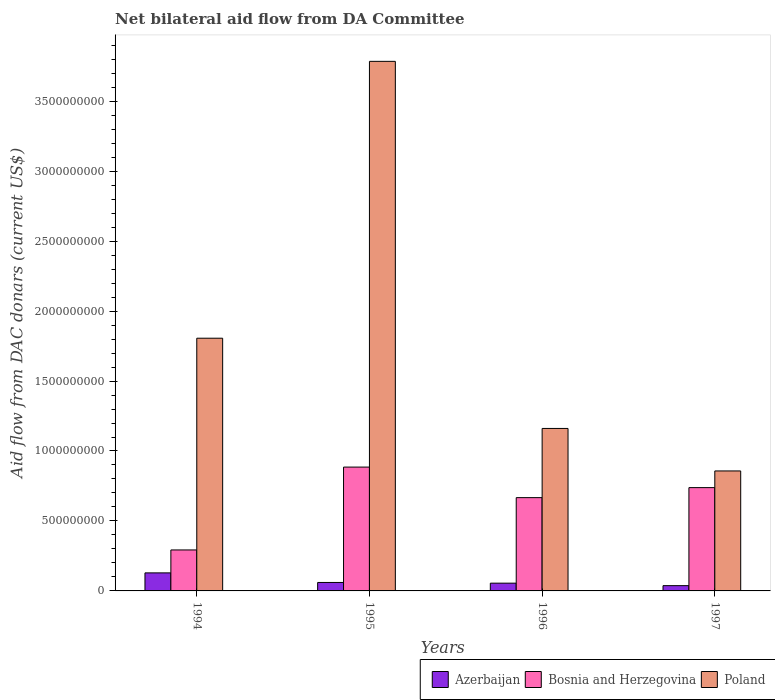How many bars are there on the 2nd tick from the left?
Your response must be concise. 3. What is the label of the 2nd group of bars from the left?
Make the answer very short. 1995. In how many cases, is the number of bars for a given year not equal to the number of legend labels?
Offer a terse response. 0. What is the aid flow in in Azerbaijan in 1995?
Your answer should be very brief. 6.05e+07. Across all years, what is the maximum aid flow in in Poland?
Provide a short and direct response. 3.78e+09. Across all years, what is the minimum aid flow in in Bosnia and Herzegovina?
Offer a terse response. 2.93e+08. In which year was the aid flow in in Azerbaijan maximum?
Offer a terse response. 1994. In which year was the aid flow in in Bosnia and Herzegovina minimum?
Ensure brevity in your answer.  1994. What is the total aid flow in in Azerbaijan in the graph?
Keep it short and to the point. 2.82e+08. What is the difference between the aid flow in in Bosnia and Herzegovina in 1995 and that in 1997?
Provide a short and direct response. 1.47e+08. What is the difference between the aid flow in in Azerbaijan in 1996 and the aid flow in in Bosnia and Herzegovina in 1995?
Your answer should be very brief. -8.30e+08. What is the average aid flow in in Poland per year?
Give a very brief answer. 1.90e+09. In the year 1996, what is the difference between the aid flow in in Azerbaijan and aid flow in in Poland?
Make the answer very short. -1.11e+09. What is the ratio of the aid flow in in Azerbaijan in 1994 to that in 1997?
Your response must be concise. 3.42. Is the difference between the aid flow in in Azerbaijan in 1995 and 1996 greater than the difference between the aid flow in in Poland in 1995 and 1996?
Keep it short and to the point. No. What is the difference between the highest and the second highest aid flow in in Bosnia and Herzegovina?
Your answer should be compact. 1.47e+08. What is the difference between the highest and the lowest aid flow in in Poland?
Provide a succinct answer. 2.93e+09. In how many years, is the aid flow in in Azerbaijan greater than the average aid flow in in Azerbaijan taken over all years?
Keep it short and to the point. 1. What does the 2nd bar from the left in 1996 represents?
Provide a succinct answer. Bosnia and Herzegovina. What does the 1st bar from the right in 1996 represents?
Your answer should be very brief. Poland. How many bars are there?
Offer a terse response. 12. Where does the legend appear in the graph?
Your answer should be very brief. Bottom right. How many legend labels are there?
Make the answer very short. 3. What is the title of the graph?
Provide a short and direct response. Net bilateral aid flow from DA Committee. Does "Bulgaria" appear as one of the legend labels in the graph?
Give a very brief answer. No. What is the label or title of the Y-axis?
Your answer should be compact. Aid flow from DAC donars (current US$). What is the Aid flow from DAC donars (current US$) in Azerbaijan in 1994?
Provide a short and direct response. 1.29e+08. What is the Aid flow from DAC donars (current US$) of Bosnia and Herzegovina in 1994?
Provide a short and direct response. 2.93e+08. What is the Aid flow from DAC donars (current US$) of Poland in 1994?
Your response must be concise. 1.81e+09. What is the Aid flow from DAC donars (current US$) of Azerbaijan in 1995?
Keep it short and to the point. 6.05e+07. What is the Aid flow from DAC donars (current US$) of Bosnia and Herzegovina in 1995?
Keep it short and to the point. 8.85e+08. What is the Aid flow from DAC donars (current US$) in Poland in 1995?
Your answer should be compact. 3.78e+09. What is the Aid flow from DAC donars (current US$) in Azerbaijan in 1996?
Provide a succinct answer. 5.54e+07. What is the Aid flow from DAC donars (current US$) in Bosnia and Herzegovina in 1996?
Offer a very short reply. 6.67e+08. What is the Aid flow from DAC donars (current US$) of Poland in 1996?
Ensure brevity in your answer.  1.16e+09. What is the Aid flow from DAC donars (current US$) of Azerbaijan in 1997?
Your answer should be compact. 3.76e+07. What is the Aid flow from DAC donars (current US$) in Bosnia and Herzegovina in 1997?
Make the answer very short. 7.38e+08. What is the Aid flow from DAC donars (current US$) in Poland in 1997?
Make the answer very short. 8.57e+08. Across all years, what is the maximum Aid flow from DAC donars (current US$) of Azerbaijan?
Your answer should be compact. 1.29e+08. Across all years, what is the maximum Aid flow from DAC donars (current US$) of Bosnia and Herzegovina?
Keep it short and to the point. 8.85e+08. Across all years, what is the maximum Aid flow from DAC donars (current US$) of Poland?
Provide a succinct answer. 3.78e+09. Across all years, what is the minimum Aid flow from DAC donars (current US$) in Azerbaijan?
Ensure brevity in your answer.  3.76e+07. Across all years, what is the minimum Aid flow from DAC donars (current US$) in Bosnia and Herzegovina?
Keep it short and to the point. 2.93e+08. Across all years, what is the minimum Aid flow from DAC donars (current US$) of Poland?
Make the answer very short. 8.57e+08. What is the total Aid flow from DAC donars (current US$) of Azerbaijan in the graph?
Give a very brief answer. 2.82e+08. What is the total Aid flow from DAC donars (current US$) of Bosnia and Herzegovina in the graph?
Give a very brief answer. 2.58e+09. What is the total Aid flow from DAC donars (current US$) in Poland in the graph?
Provide a short and direct response. 7.61e+09. What is the difference between the Aid flow from DAC donars (current US$) of Azerbaijan in 1994 and that in 1995?
Offer a terse response. 6.84e+07. What is the difference between the Aid flow from DAC donars (current US$) of Bosnia and Herzegovina in 1994 and that in 1995?
Give a very brief answer. -5.92e+08. What is the difference between the Aid flow from DAC donars (current US$) in Poland in 1994 and that in 1995?
Make the answer very short. -1.98e+09. What is the difference between the Aid flow from DAC donars (current US$) in Azerbaijan in 1994 and that in 1996?
Your answer should be compact. 7.34e+07. What is the difference between the Aid flow from DAC donars (current US$) of Bosnia and Herzegovina in 1994 and that in 1996?
Offer a terse response. -3.74e+08. What is the difference between the Aid flow from DAC donars (current US$) in Poland in 1994 and that in 1996?
Make the answer very short. 6.45e+08. What is the difference between the Aid flow from DAC donars (current US$) of Azerbaijan in 1994 and that in 1997?
Your answer should be compact. 9.12e+07. What is the difference between the Aid flow from DAC donars (current US$) of Bosnia and Herzegovina in 1994 and that in 1997?
Provide a short and direct response. -4.45e+08. What is the difference between the Aid flow from DAC donars (current US$) in Poland in 1994 and that in 1997?
Your answer should be compact. 9.49e+08. What is the difference between the Aid flow from DAC donars (current US$) of Azerbaijan in 1995 and that in 1996?
Offer a terse response. 5.03e+06. What is the difference between the Aid flow from DAC donars (current US$) of Bosnia and Herzegovina in 1995 and that in 1996?
Ensure brevity in your answer.  2.18e+08. What is the difference between the Aid flow from DAC donars (current US$) in Poland in 1995 and that in 1996?
Provide a short and direct response. 2.62e+09. What is the difference between the Aid flow from DAC donars (current US$) of Azerbaijan in 1995 and that in 1997?
Keep it short and to the point. 2.28e+07. What is the difference between the Aid flow from DAC donars (current US$) in Bosnia and Herzegovina in 1995 and that in 1997?
Your response must be concise. 1.47e+08. What is the difference between the Aid flow from DAC donars (current US$) in Poland in 1995 and that in 1997?
Ensure brevity in your answer.  2.93e+09. What is the difference between the Aid flow from DAC donars (current US$) in Azerbaijan in 1996 and that in 1997?
Provide a short and direct response. 1.78e+07. What is the difference between the Aid flow from DAC donars (current US$) in Bosnia and Herzegovina in 1996 and that in 1997?
Your response must be concise. -7.16e+07. What is the difference between the Aid flow from DAC donars (current US$) in Poland in 1996 and that in 1997?
Your response must be concise. 3.04e+08. What is the difference between the Aid flow from DAC donars (current US$) in Azerbaijan in 1994 and the Aid flow from DAC donars (current US$) in Bosnia and Herzegovina in 1995?
Your answer should be compact. -7.56e+08. What is the difference between the Aid flow from DAC donars (current US$) in Azerbaijan in 1994 and the Aid flow from DAC donars (current US$) in Poland in 1995?
Offer a very short reply. -3.66e+09. What is the difference between the Aid flow from DAC donars (current US$) in Bosnia and Herzegovina in 1994 and the Aid flow from DAC donars (current US$) in Poland in 1995?
Ensure brevity in your answer.  -3.49e+09. What is the difference between the Aid flow from DAC donars (current US$) in Azerbaijan in 1994 and the Aid flow from DAC donars (current US$) in Bosnia and Herzegovina in 1996?
Provide a succinct answer. -5.38e+08. What is the difference between the Aid flow from DAC donars (current US$) in Azerbaijan in 1994 and the Aid flow from DAC donars (current US$) in Poland in 1996?
Your answer should be very brief. -1.03e+09. What is the difference between the Aid flow from DAC donars (current US$) in Bosnia and Herzegovina in 1994 and the Aid flow from DAC donars (current US$) in Poland in 1996?
Your answer should be very brief. -8.68e+08. What is the difference between the Aid flow from DAC donars (current US$) of Azerbaijan in 1994 and the Aid flow from DAC donars (current US$) of Bosnia and Herzegovina in 1997?
Keep it short and to the point. -6.09e+08. What is the difference between the Aid flow from DAC donars (current US$) of Azerbaijan in 1994 and the Aid flow from DAC donars (current US$) of Poland in 1997?
Your response must be concise. -7.29e+08. What is the difference between the Aid flow from DAC donars (current US$) of Bosnia and Herzegovina in 1994 and the Aid flow from DAC donars (current US$) of Poland in 1997?
Offer a very short reply. -5.65e+08. What is the difference between the Aid flow from DAC donars (current US$) of Azerbaijan in 1995 and the Aid flow from DAC donars (current US$) of Bosnia and Herzegovina in 1996?
Give a very brief answer. -6.06e+08. What is the difference between the Aid flow from DAC donars (current US$) in Azerbaijan in 1995 and the Aid flow from DAC donars (current US$) in Poland in 1996?
Make the answer very short. -1.10e+09. What is the difference between the Aid flow from DAC donars (current US$) in Bosnia and Herzegovina in 1995 and the Aid flow from DAC donars (current US$) in Poland in 1996?
Provide a succinct answer. -2.76e+08. What is the difference between the Aid flow from DAC donars (current US$) in Azerbaijan in 1995 and the Aid flow from DAC donars (current US$) in Bosnia and Herzegovina in 1997?
Offer a terse response. -6.78e+08. What is the difference between the Aid flow from DAC donars (current US$) in Azerbaijan in 1995 and the Aid flow from DAC donars (current US$) in Poland in 1997?
Your response must be concise. -7.97e+08. What is the difference between the Aid flow from DAC donars (current US$) in Bosnia and Herzegovina in 1995 and the Aid flow from DAC donars (current US$) in Poland in 1997?
Offer a very short reply. 2.76e+07. What is the difference between the Aid flow from DAC donars (current US$) in Azerbaijan in 1996 and the Aid flow from DAC donars (current US$) in Bosnia and Herzegovina in 1997?
Provide a short and direct response. -6.83e+08. What is the difference between the Aid flow from DAC donars (current US$) in Azerbaijan in 1996 and the Aid flow from DAC donars (current US$) in Poland in 1997?
Offer a terse response. -8.02e+08. What is the difference between the Aid flow from DAC donars (current US$) of Bosnia and Herzegovina in 1996 and the Aid flow from DAC donars (current US$) of Poland in 1997?
Provide a succinct answer. -1.91e+08. What is the average Aid flow from DAC donars (current US$) of Azerbaijan per year?
Your answer should be very brief. 7.06e+07. What is the average Aid flow from DAC donars (current US$) in Bosnia and Herzegovina per year?
Provide a succinct answer. 6.46e+08. What is the average Aid flow from DAC donars (current US$) of Poland per year?
Make the answer very short. 1.90e+09. In the year 1994, what is the difference between the Aid flow from DAC donars (current US$) in Azerbaijan and Aid flow from DAC donars (current US$) in Bosnia and Herzegovina?
Make the answer very short. -1.64e+08. In the year 1994, what is the difference between the Aid flow from DAC donars (current US$) in Azerbaijan and Aid flow from DAC donars (current US$) in Poland?
Your answer should be very brief. -1.68e+09. In the year 1994, what is the difference between the Aid flow from DAC donars (current US$) in Bosnia and Herzegovina and Aid flow from DAC donars (current US$) in Poland?
Give a very brief answer. -1.51e+09. In the year 1995, what is the difference between the Aid flow from DAC donars (current US$) in Azerbaijan and Aid flow from DAC donars (current US$) in Bosnia and Herzegovina?
Offer a terse response. -8.25e+08. In the year 1995, what is the difference between the Aid flow from DAC donars (current US$) in Azerbaijan and Aid flow from DAC donars (current US$) in Poland?
Your answer should be very brief. -3.72e+09. In the year 1995, what is the difference between the Aid flow from DAC donars (current US$) of Bosnia and Herzegovina and Aid flow from DAC donars (current US$) of Poland?
Give a very brief answer. -2.90e+09. In the year 1996, what is the difference between the Aid flow from DAC donars (current US$) of Azerbaijan and Aid flow from DAC donars (current US$) of Bosnia and Herzegovina?
Offer a very short reply. -6.11e+08. In the year 1996, what is the difference between the Aid flow from DAC donars (current US$) of Azerbaijan and Aid flow from DAC donars (current US$) of Poland?
Your answer should be compact. -1.11e+09. In the year 1996, what is the difference between the Aid flow from DAC donars (current US$) in Bosnia and Herzegovina and Aid flow from DAC donars (current US$) in Poland?
Your answer should be compact. -4.94e+08. In the year 1997, what is the difference between the Aid flow from DAC donars (current US$) of Azerbaijan and Aid flow from DAC donars (current US$) of Bosnia and Herzegovina?
Your answer should be very brief. -7.01e+08. In the year 1997, what is the difference between the Aid flow from DAC donars (current US$) of Azerbaijan and Aid flow from DAC donars (current US$) of Poland?
Offer a terse response. -8.20e+08. In the year 1997, what is the difference between the Aid flow from DAC donars (current US$) in Bosnia and Herzegovina and Aid flow from DAC donars (current US$) in Poland?
Your answer should be compact. -1.19e+08. What is the ratio of the Aid flow from DAC donars (current US$) in Azerbaijan in 1994 to that in 1995?
Provide a succinct answer. 2.13. What is the ratio of the Aid flow from DAC donars (current US$) in Bosnia and Herzegovina in 1994 to that in 1995?
Offer a terse response. 0.33. What is the ratio of the Aid flow from DAC donars (current US$) of Poland in 1994 to that in 1995?
Ensure brevity in your answer.  0.48. What is the ratio of the Aid flow from DAC donars (current US$) of Azerbaijan in 1994 to that in 1996?
Ensure brevity in your answer.  2.32. What is the ratio of the Aid flow from DAC donars (current US$) of Bosnia and Herzegovina in 1994 to that in 1996?
Your answer should be very brief. 0.44. What is the ratio of the Aid flow from DAC donars (current US$) of Poland in 1994 to that in 1996?
Make the answer very short. 1.56. What is the ratio of the Aid flow from DAC donars (current US$) of Azerbaijan in 1994 to that in 1997?
Ensure brevity in your answer.  3.42. What is the ratio of the Aid flow from DAC donars (current US$) in Bosnia and Herzegovina in 1994 to that in 1997?
Ensure brevity in your answer.  0.4. What is the ratio of the Aid flow from DAC donars (current US$) of Poland in 1994 to that in 1997?
Provide a short and direct response. 2.11. What is the ratio of the Aid flow from DAC donars (current US$) in Azerbaijan in 1995 to that in 1996?
Provide a succinct answer. 1.09. What is the ratio of the Aid flow from DAC donars (current US$) of Bosnia and Herzegovina in 1995 to that in 1996?
Keep it short and to the point. 1.33. What is the ratio of the Aid flow from DAC donars (current US$) of Poland in 1995 to that in 1996?
Provide a succinct answer. 3.26. What is the ratio of the Aid flow from DAC donars (current US$) in Azerbaijan in 1995 to that in 1997?
Your answer should be very brief. 1.61. What is the ratio of the Aid flow from DAC donars (current US$) in Bosnia and Herzegovina in 1995 to that in 1997?
Your answer should be compact. 1.2. What is the ratio of the Aid flow from DAC donars (current US$) in Poland in 1995 to that in 1997?
Your response must be concise. 4.41. What is the ratio of the Aid flow from DAC donars (current US$) in Azerbaijan in 1996 to that in 1997?
Ensure brevity in your answer.  1.47. What is the ratio of the Aid flow from DAC donars (current US$) in Bosnia and Herzegovina in 1996 to that in 1997?
Ensure brevity in your answer.  0.9. What is the ratio of the Aid flow from DAC donars (current US$) in Poland in 1996 to that in 1997?
Offer a very short reply. 1.35. What is the difference between the highest and the second highest Aid flow from DAC donars (current US$) of Azerbaijan?
Your answer should be compact. 6.84e+07. What is the difference between the highest and the second highest Aid flow from DAC donars (current US$) in Bosnia and Herzegovina?
Offer a terse response. 1.47e+08. What is the difference between the highest and the second highest Aid flow from DAC donars (current US$) of Poland?
Ensure brevity in your answer.  1.98e+09. What is the difference between the highest and the lowest Aid flow from DAC donars (current US$) in Azerbaijan?
Ensure brevity in your answer.  9.12e+07. What is the difference between the highest and the lowest Aid flow from DAC donars (current US$) of Bosnia and Herzegovina?
Offer a terse response. 5.92e+08. What is the difference between the highest and the lowest Aid flow from DAC donars (current US$) of Poland?
Your response must be concise. 2.93e+09. 